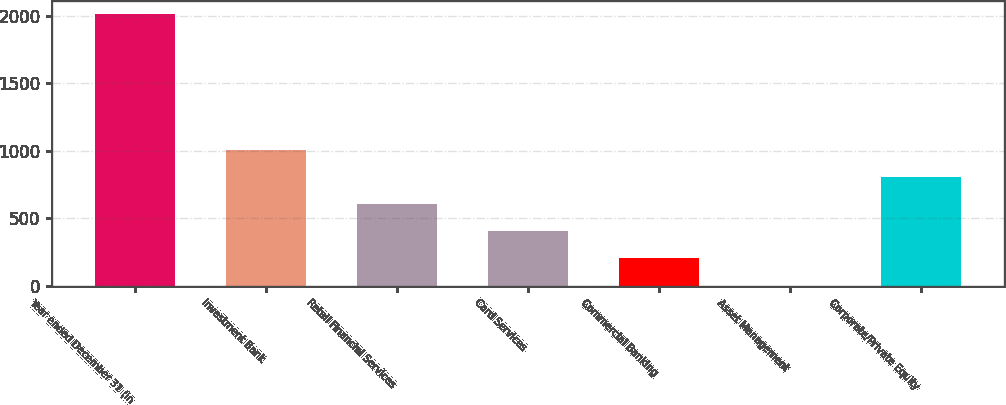Convert chart to OTSL. <chart><loc_0><loc_0><loc_500><loc_500><bar_chart><fcel>Year ended December 31 (in<fcel>Investment Bank<fcel>Retail Financial Services<fcel>Card Services<fcel>Commercial Banking<fcel>Asset Management<fcel>Corporate/Private Equity<nl><fcel>2008<fcel>1005.5<fcel>604.5<fcel>404<fcel>203.5<fcel>3<fcel>805<nl></chart> 